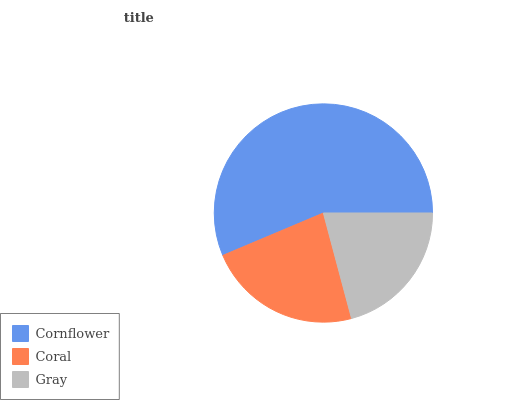Is Gray the minimum?
Answer yes or no. Yes. Is Cornflower the maximum?
Answer yes or no. Yes. Is Coral the minimum?
Answer yes or no. No. Is Coral the maximum?
Answer yes or no. No. Is Cornflower greater than Coral?
Answer yes or no. Yes. Is Coral less than Cornflower?
Answer yes or no. Yes. Is Coral greater than Cornflower?
Answer yes or no. No. Is Cornflower less than Coral?
Answer yes or no. No. Is Coral the high median?
Answer yes or no. Yes. Is Coral the low median?
Answer yes or no. Yes. Is Gray the high median?
Answer yes or no. No. Is Cornflower the low median?
Answer yes or no. No. 